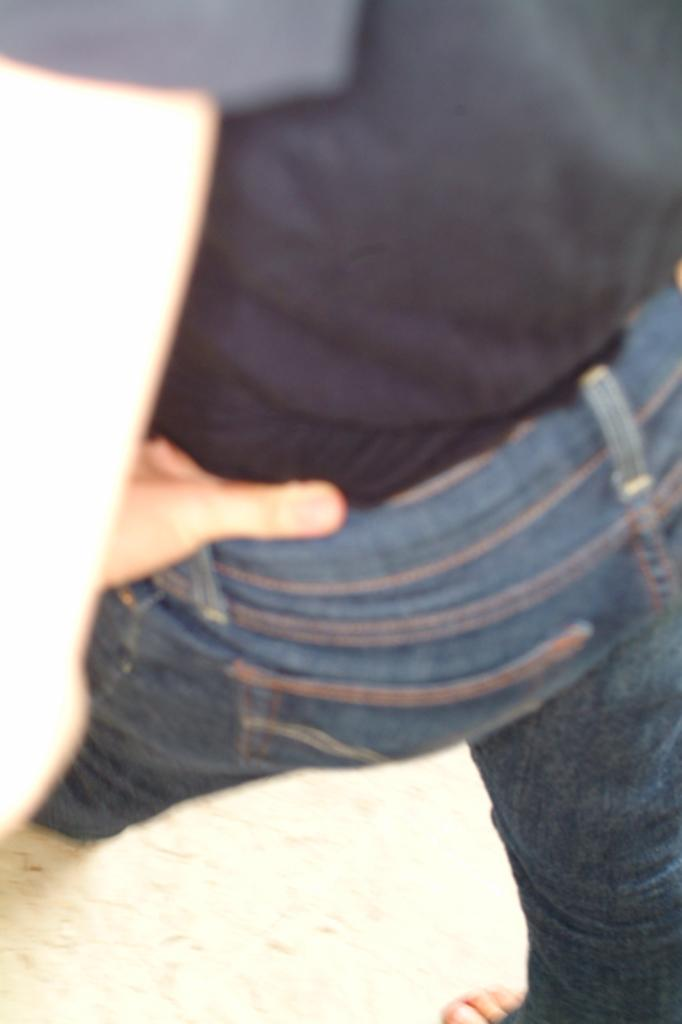What is at the bottom of the image? identifying the main subject in the image, which is the floor. Then, we describe the action of the man in the image, who is walking on the floor. Finally, we mention the man's clothing, specifically his T-shirt and jeans pants. What type of quince is being used as a prop in the image? There is no quince present in the image. What part of the man's body is not visible in the image? It is impossible to determine which part of the man's body is not visible in the image, as the provided facts do not give enough information about his position or the camera angle. 